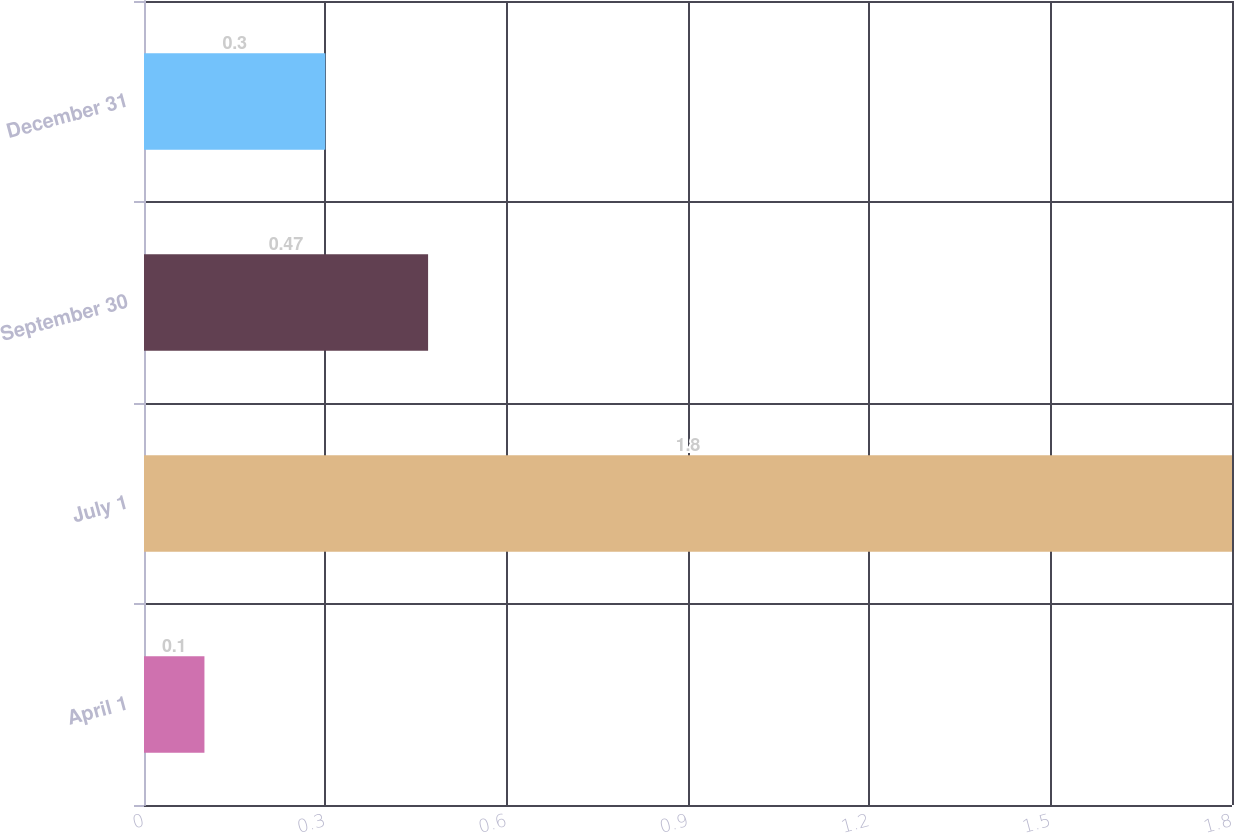Convert chart to OTSL. <chart><loc_0><loc_0><loc_500><loc_500><bar_chart><fcel>April 1<fcel>July 1<fcel>September 30<fcel>December 31<nl><fcel>0.1<fcel>1.8<fcel>0.47<fcel>0.3<nl></chart> 